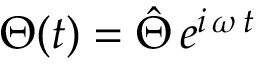<formula> <loc_0><loc_0><loc_500><loc_500>\Theta ( t ) = \hat { \Theta } \, e ^ { i \, \omega \, t }</formula> 